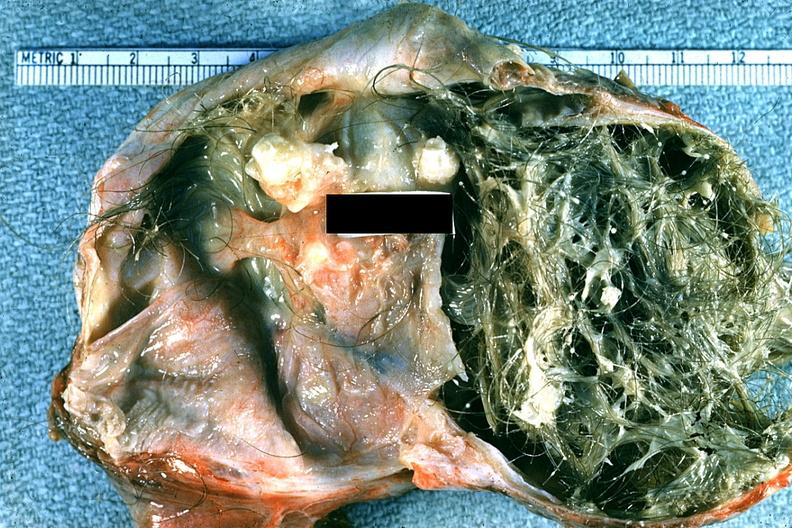does this image show good example typical dermoid with hair and sebaceous material?
Answer the question using a single word or phrase. Yes 